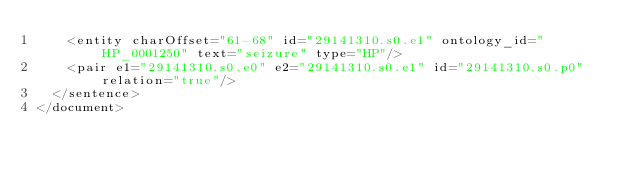Convert code to text. <code><loc_0><loc_0><loc_500><loc_500><_XML_>    <entity charOffset="61-68" id="29141310.s0.e1" ontology_id="HP_0001250" text="seizure" type="HP"/>
    <pair e1="29141310.s0.e0" e2="29141310.s0.e1" id="29141310.s0.p0" relation="true"/>
  </sentence>
</document>
</code> 